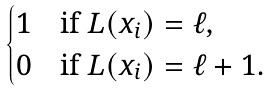Convert formula to latex. <formula><loc_0><loc_0><loc_500><loc_500>\begin{cases} 1 & \text {if } L ( x _ { i } ) = \ell , \\ 0 & \text {if } L ( x _ { i } ) = \ell + 1 . \end{cases}</formula> 